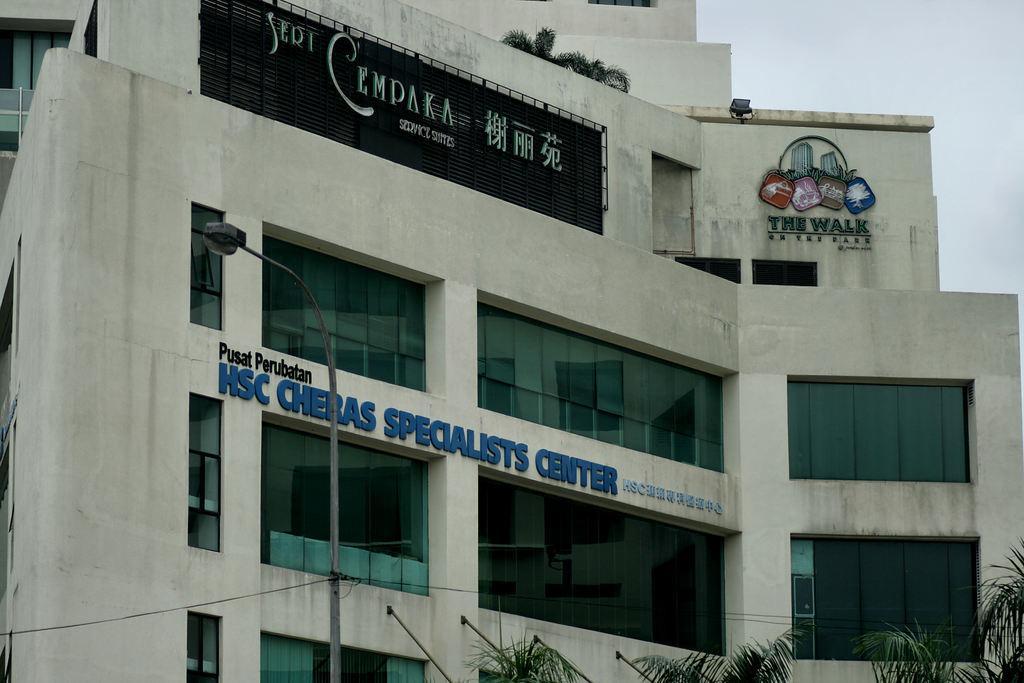Can you describe this image briefly? In this image we can see a building, light pole, texts written on the wall, windows, glasses, trees, wires and sky. 